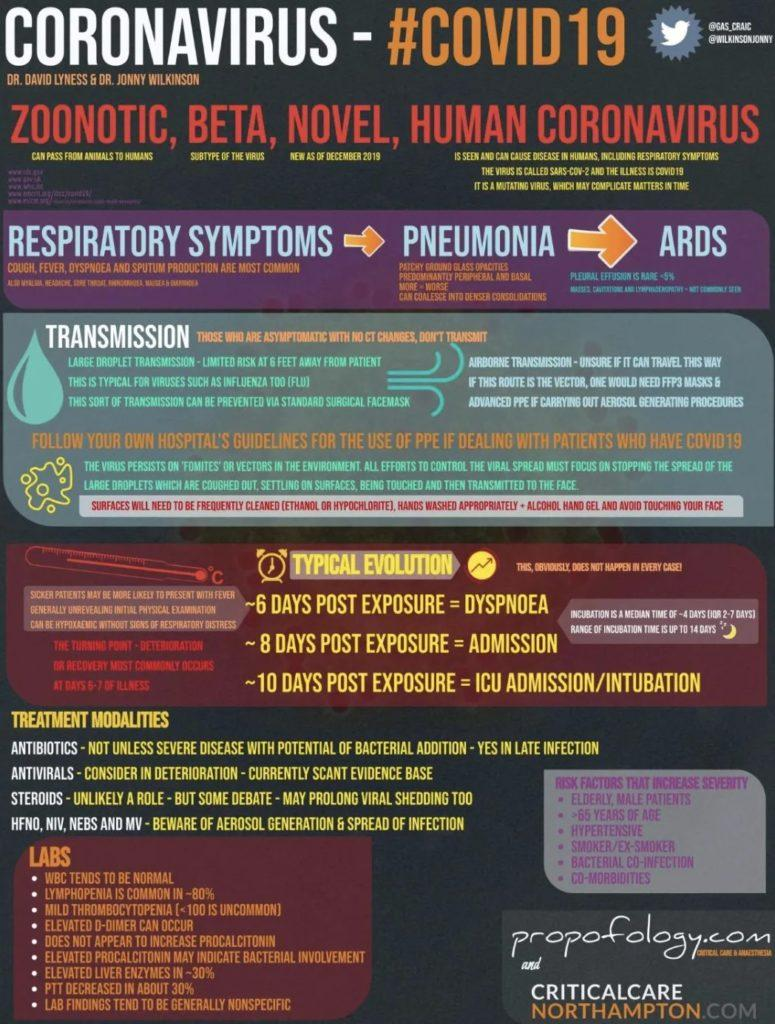Mention a couple of crucial points in this snapshot. Zoonotic viruses are those that can be transmitted from animals to humans. The beta type of virus is a subtype. 